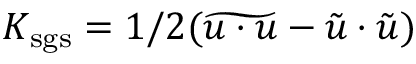Convert formula to latex. <formula><loc_0><loc_0><loc_500><loc_500>K _ { s g s } = 1 / 2 ( \widetilde { u \cdot u } - \tilde { u } \cdot \tilde { u } )</formula> 